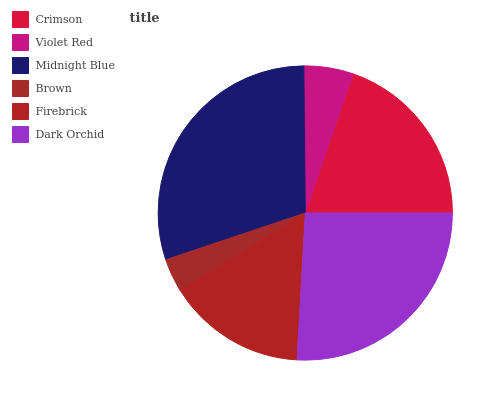Is Brown the minimum?
Answer yes or no. Yes. Is Midnight Blue the maximum?
Answer yes or no. Yes. Is Violet Red the minimum?
Answer yes or no. No. Is Violet Red the maximum?
Answer yes or no. No. Is Crimson greater than Violet Red?
Answer yes or no. Yes. Is Violet Red less than Crimson?
Answer yes or no. Yes. Is Violet Red greater than Crimson?
Answer yes or no. No. Is Crimson less than Violet Red?
Answer yes or no. No. Is Crimson the high median?
Answer yes or no. Yes. Is Firebrick the low median?
Answer yes or no. Yes. Is Firebrick the high median?
Answer yes or no. No. Is Dark Orchid the low median?
Answer yes or no. No. 